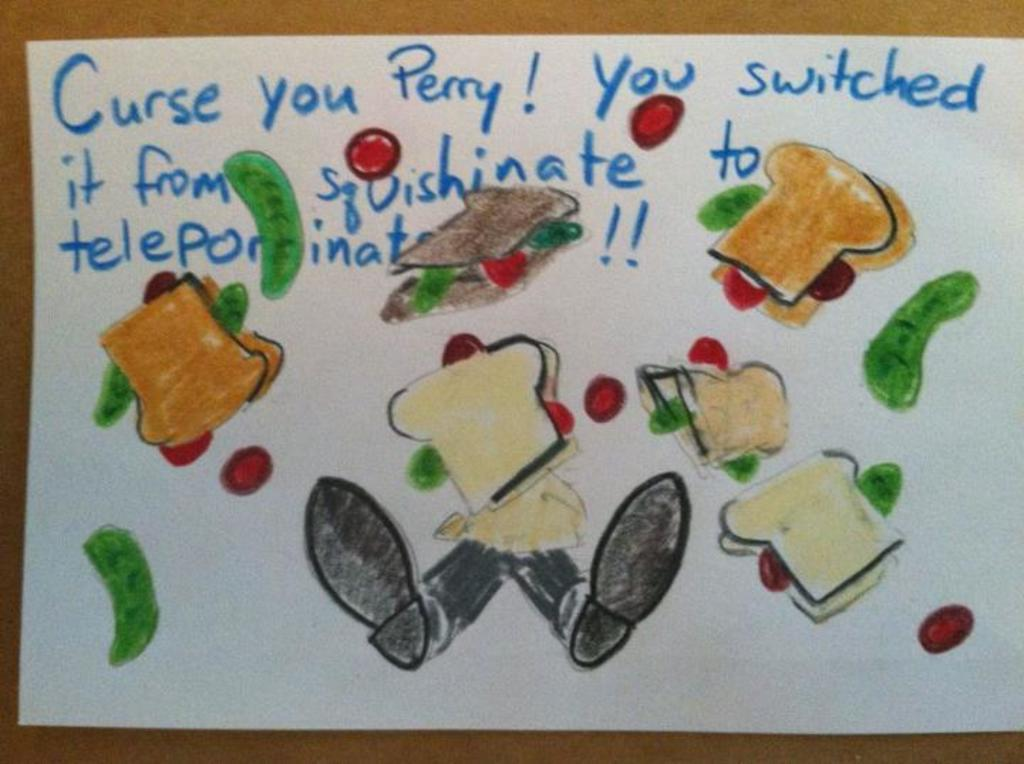What is depicted on the white paper in the image? There is a drawing on a white paper in the image. What elements are included in the drawing? The drawing includes some text and some images. What type of club is being used to create the drawing in the image? There is no club present in the image; it is a drawing on a white paper. How does the drawing create a sense of harmony in the image? The drawing does not create a sense of harmony in the image, as the facts provided do not mention any specific theme or style in the drawing. 